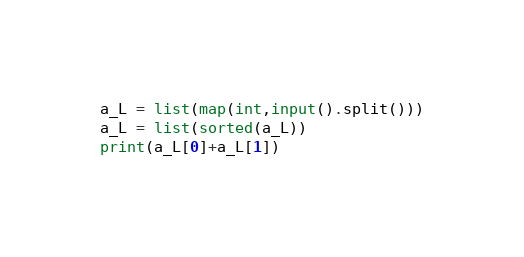<code> <loc_0><loc_0><loc_500><loc_500><_Python_>a_L = list(map(int,input().split()))
a_L = list(sorted(a_L))
print(a_L[0]+a_L[1])</code> 